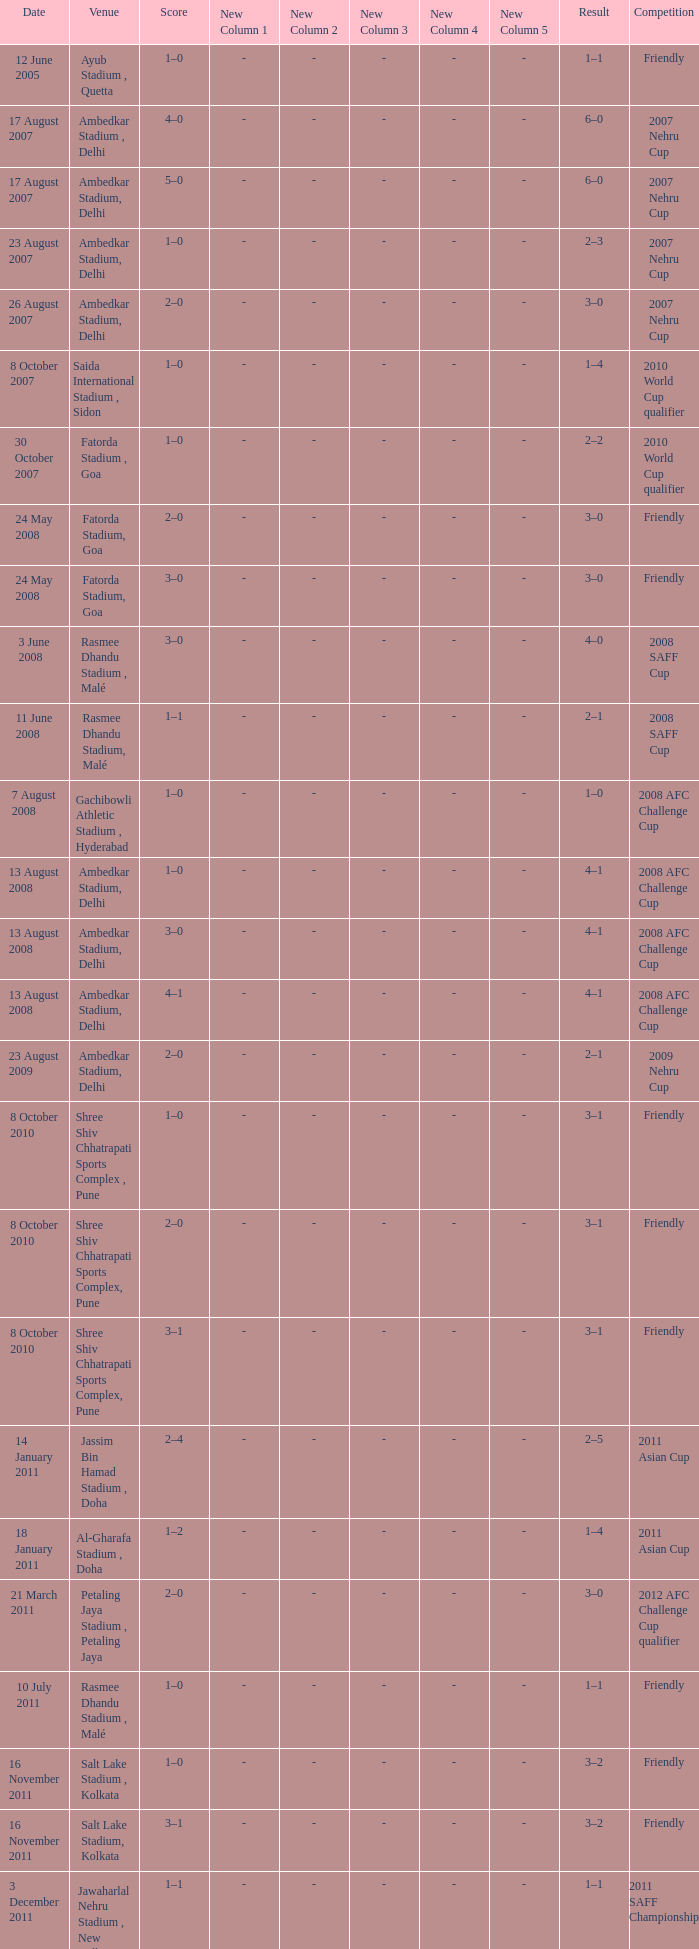Tell me the score on 22 august 2012 1–0. 